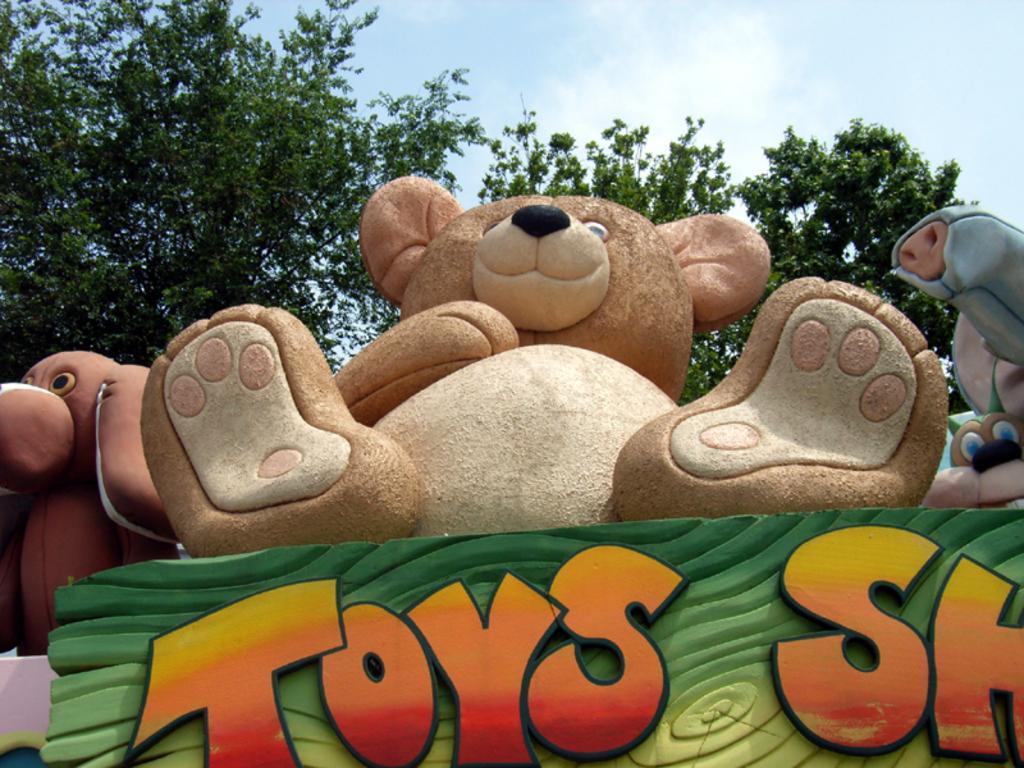How would you summarize this image in a sentence or two? In this image I can see few toys which are in brown and blue color. And I can see the board toys shop is written. And it is in green, red and yellow color. In the background I can see the trees and the blue sky. 